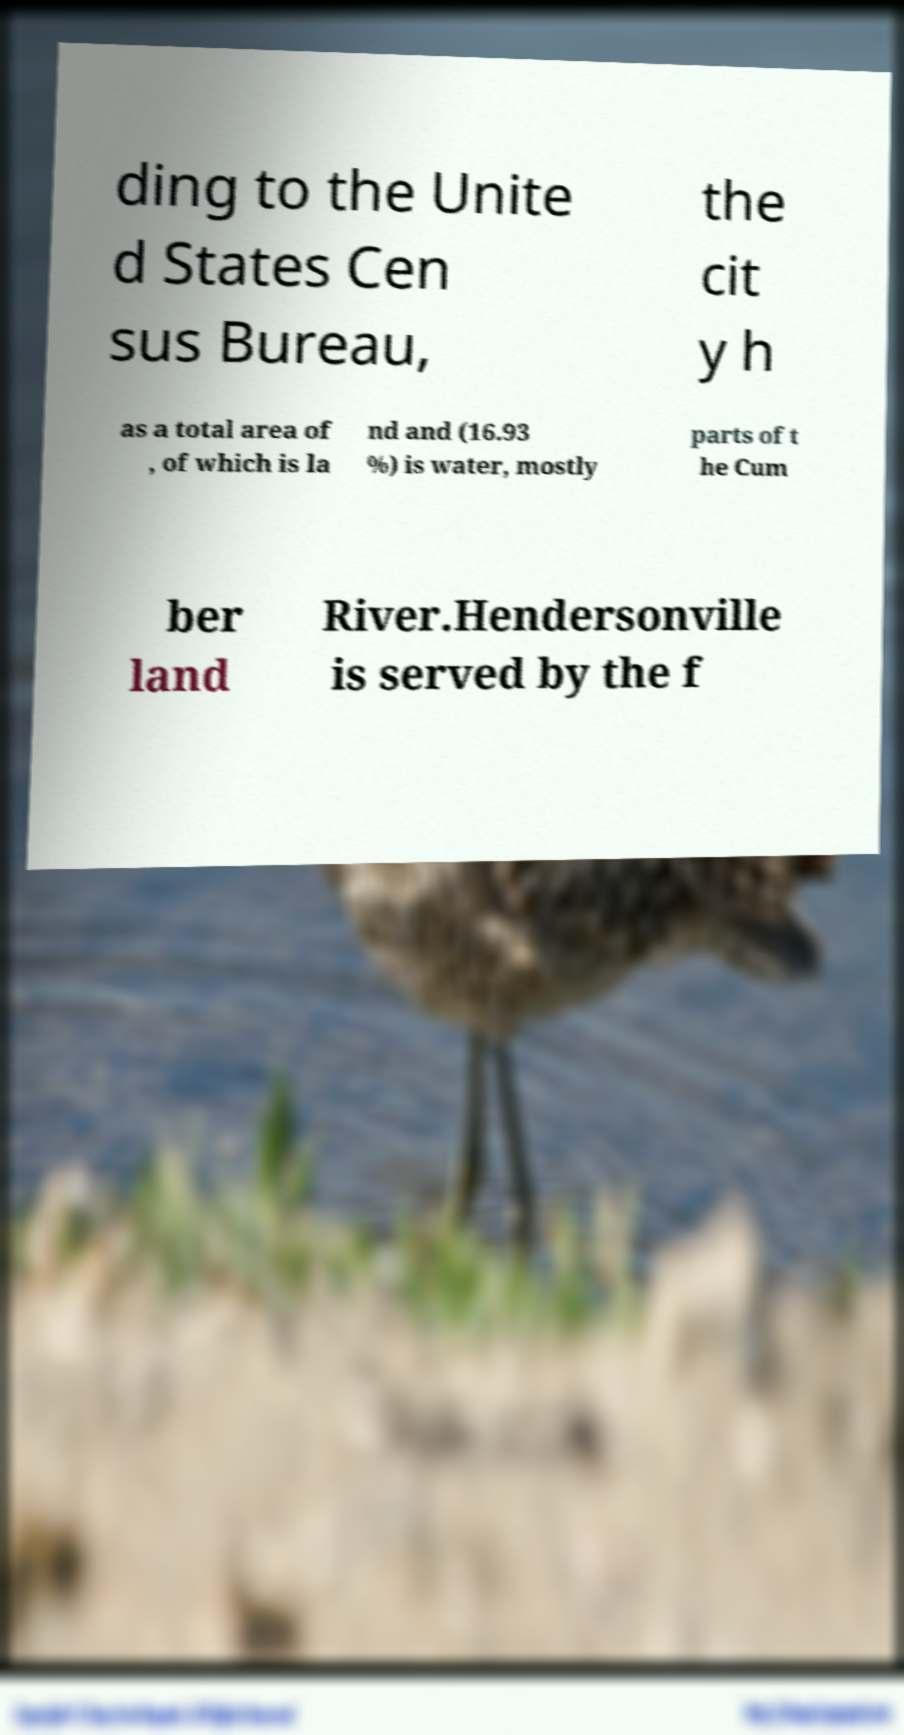Please read and relay the text visible in this image. What does it say? ding to the Unite d States Cen sus Bureau, the cit y h as a total area of , of which is la nd and (16.93 %) is water, mostly parts of t he Cum ber land River.Hendersonville is served by the f 